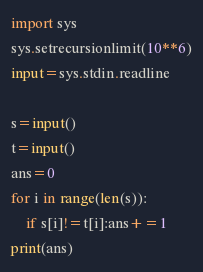<code> <loc_0><loc_0><loc_500><loc_500><_Python_>import sys
sys.setrecursionlimit(10**6)
input=sys.stdin.readline

s=input()
t=input()
ans=0
for i in range(len(s)):
    if s[i]!=t[i]:ans+=1
print(ans)</code> 